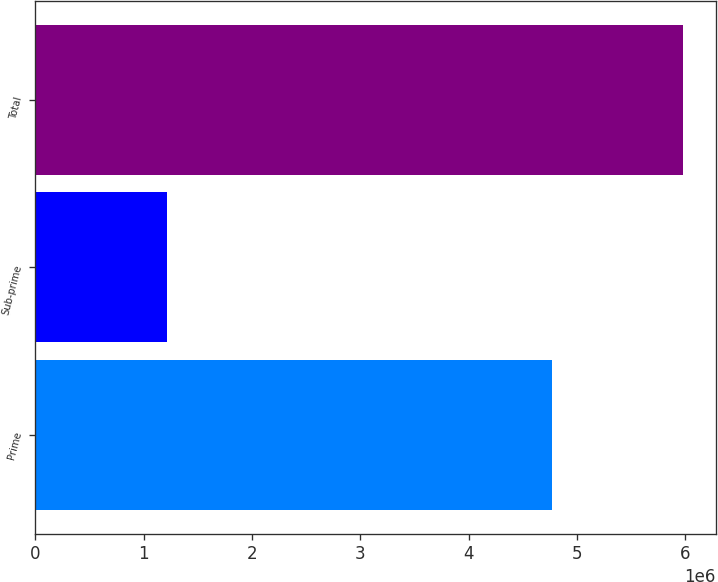<chart> <loc_0><loc_0><loc_500><loc_500><bar_chart><fcel>Prime<fcel>Sub-prime<fcel>Total<nl><fcel>4.76842e+06<fcel>1.21379e+06<fcel>5.98221e+06<nl></chart> 